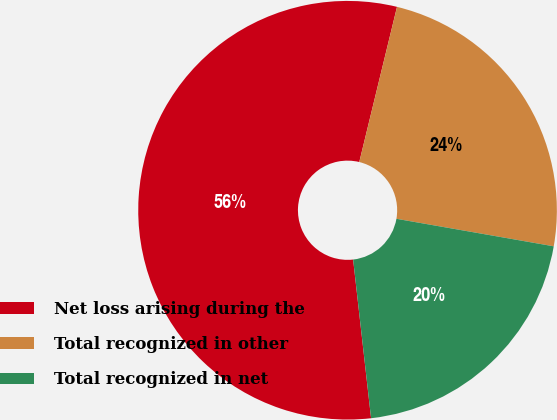Convert chart to OTSL. <chart><loc_0><loc_0><loc_500><loc_500><pie_chart><fcel>Net loss arising during the<fcel>Total recognized in other<fcel>Total recognized in net<nl><fcel>55.59%<fcel>23.96%<fcel>20.45%<nl></chart> 